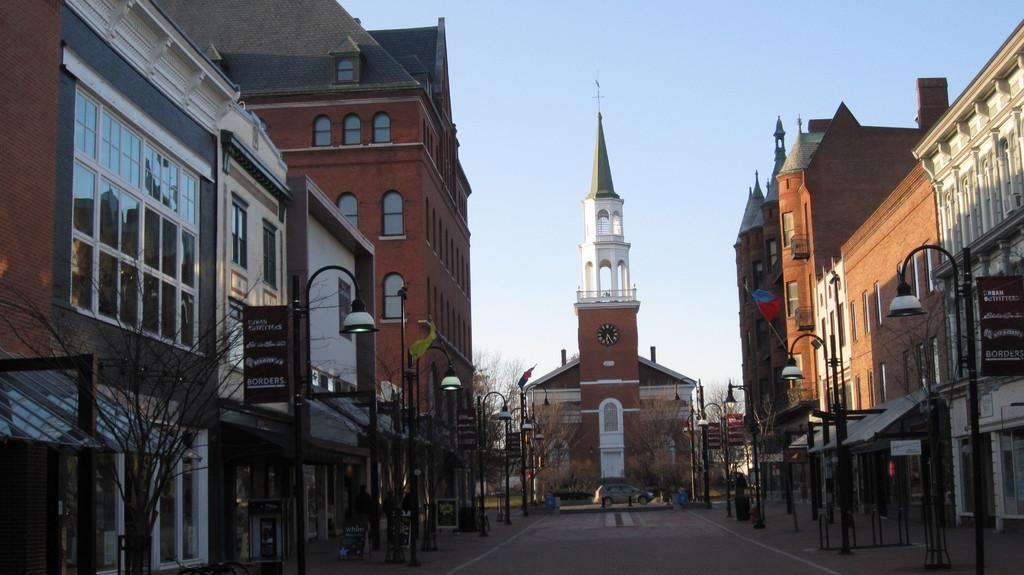What type of structure is visible in the image? There is a building in the image. What is located in the middle of the image? There is a road in the middle of the image. What is the tall structure in the front of the image? There is a clock tower in the front of the image. What is visible at the top of the image? The sky is visible at the top of the image. What type of vegetation is on the left side of the image? There is a tree on the left side of the image. How many legs can be seen on the tree in the image? Trees do not have legs, so this question is not applicable to the image. What type of toys are scattered around the building in the image? There are no toys present in the image. 